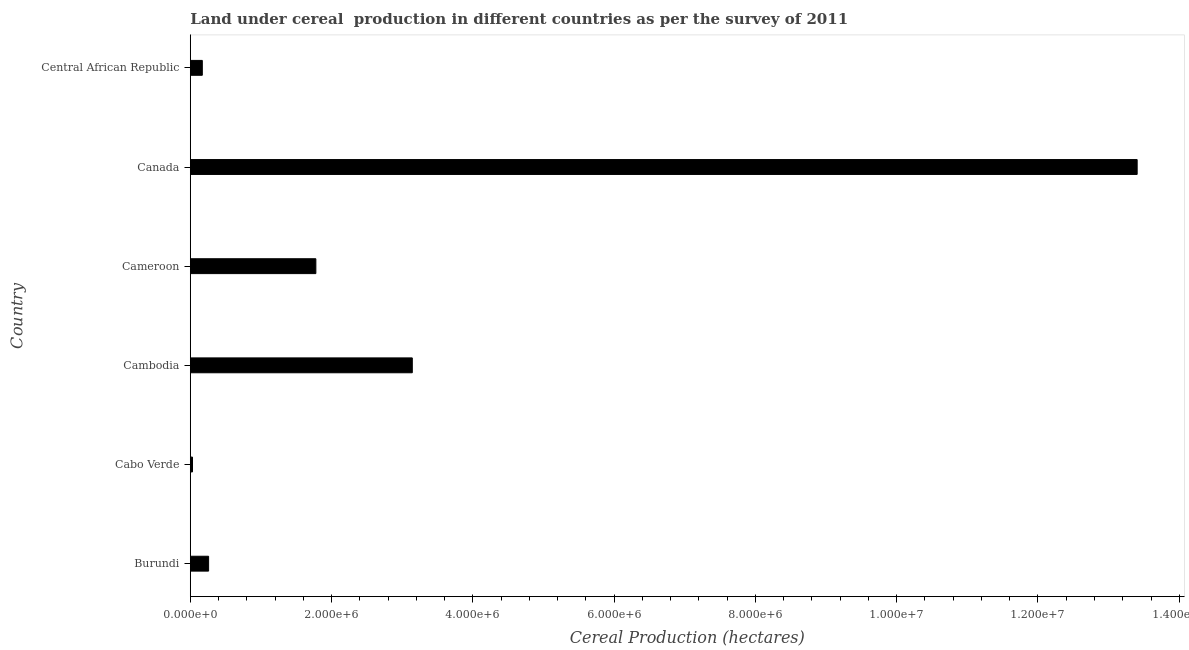What is the title of the graph?
Your response must be concise. Land under cereal  production in different countries as per the survey of 2011. What is the label or title of the X-axis?
Make the answer very short. Cereal Production (hectares). What is the land under cereal production in Cabo Verde?
Make the answer very short. 3.13e+04. Across all countries, what is the maximum land under cereal production?
Make the answer very short. 1.34e+07. Across all countries, what is the minimum land under cereal production?
Offer a very short reply. 3.13e+04. In which country was the land under cereal production minimum?
Your answer should be very brief. Cabo Verde. What is the sum of the land under cereal production?
Offer a terse response. 1.88e+07. What is the difference between the land under cereal production in Cambodia and Canada?
Your response must be concise. -1.03e+07. What is the average land under cereal production per country?
Keep it short and to the point. 3.13e+06. What is the median land under cereal production?
Offer a very short reply. 1.02e+06. What is the ratio of the land under cereal production in Canada to that in Central African Republic?
Keep it short and to the point. 78.75. Is the land under cereal production in Canada less than that in Central African Republic?
Offer a very short reply. No. What is the difference between the highest and the second highest land under cereal production?
Your response must be concise. 1.03e+07. Is the sum of the land under cereal production in Cabo Verde and Central African Republic greater than the maximum land under cereal production across all countries?
Offer a very short reply. No. What is the difference between the highest and the lowest land under cereal production?
Your answer should be very brief. 1.34e+07. In how many countries, is the land under cereal production greater than the average land under cereal production taken over all countries?
Provide a short and direct response. 2. Are all the bars in the graph horizontal?
Keep it short and to the point. Yes. How many countries are there in the graph?
Provide a short and direct response. 6. Are the values on the major ticks of X-axis written in scientific E-notation?
Your answer should be compact. Yes. What is the Cereal Production (hectares) in Burundi?
Make the answer very short. 2.59e+05. What is the Cereal Production (hectares) in Cabo Verde?
Give a very brief answer. 3.13e+04. What is the Cereal Production (hectares) in Cambodia?
Ensure brevity in your answer.  3.14e+06. What is the Cereal Production (hectares) in Cameroon?
Keep it short and to the point. 1.78e+06. What is the Cereal Production (hectares) of Canada?
Offer a terse response. 1.34e+07. What is the Cereal Production (hectares) in Central African Republic?
Provide a short and direct response. 1.70e+05. What is the difference between the Cereal Production (hectares) in Burundi and Cabo Verde?
Keep it short and to the point. 2.28e+05. What is the difference between the Cereal Production (hectares) in Burundi and Cambodia?
Make the answer very short. -2.88e+06. What is the difference between the Cereal Production (hectares) in Burundi and Cameroon?
Give a very brief answer. -1.52e+06. What is the difference between the Cereal Production (hectares) in Burundi and Canada?
Offer a terse response. -1.31e+07. What is the difference between the Cereal Production (hectares) in Burundi and Central African Republic?
Offer a terse response. 8.90e+04. What is the difference between the Cereal Production (hectares) in Cabo Verde and Cambodia?
Your answer should be compact. -3.11e+06. What is the difference between the Cereal Production (hectares) in Cabo Verde and Cameroon?
Ensure brevity in your answer.  -1.75e+06. What is the difference between the Cereal Production (hectares) in Cabo Verde and Canada?
Your response must be concise. -1.34e+07. What is the difference between the Cereal Production (hectares) in Cabo Verde and Central African Republic?
Offer a terse response. -1.39e+05. What is the difference between the Cereal Production (hectares) in Cambodia and Cameroon?
Your response must be concise. 1.37e+06. What is the difference between the Cereal Production (hectares) in Cambodia and Canada?
Offer a very short reply. -1.03e+07. What is the difference between the Cereal Production (hectares) in Cambodia and Central African Republic?
Offer a very short reply. 2.97e+06. What is the difference between the Cereal Production (hectares) in Cameroon and Canada?
Offer a very short reply. -1.16e+07. What is the difference between the Cereal Production (hectares) in Cameroon and Central African Republic?
Keep it short and to the point. 1.61e+06. What is the difference between the Cereal Production (hectares) in Canada and Central African Republic?
Make the answer very short. 1.32e+07. What is the ratio of the Cereal Production (hectares) in Burundi to that in Cabo Verde?
Offer a very short reply. 8.28. What is the ratio of the Cereal Production (hectares) in Burundi to that in Cambodia?
Provide a short and direct response. 0.08. What is the ratio of the Cereal Production (hectares) in Burundi to that in Cameroon?
Keep it short and to the point. 0.15. What is the ratio of the Cereal Production (hectares) in Burundi to that in Canada?
Keep it short and to the point. 0.02. What is the ratio of the Cereal Production (hectares) in Burundi to that in Central African Republic?
Your answer should be very brief. 1.52. What is the ratio of the Cereal Production (hectares) in Cabo Verde to that in Cameroon?
Your answer should be compact. 0.02. What is the ratio of the Cereal Production (hectares) in Cabo Verde to that in Canada?
Ensure brevity in your answer.  0. What is the ratio of the Cereal Production (hectares) in Cabo Verde to that in Central African Republic?
Keep it short and to the point. 0.18. What is the ratio of the Cereal Production (hectares) in Cambodia to that in Cameroon?
Offer a terse response. 1.77. What is the ratio of the Cereal Production (hectares) in Cambodia to that in Canada?
Give a very brief answer. 0.23. What is the ratio of the Cereal Production (hectares) in Cambodia to that in Central African Republic?
Your answer should be very brief. 18.46. What is the ratio of the Cereal Production (hectares) in Cameroon to that in Canada?
Keep it short and to the point. 0.13. What is the ratio of the Cereal Production (hectares) in Cameroon to that in Central African Republic?
Ensure brevity in your answer.  10.44. What is the ratio of the Cereal Production (hectares) in Canada to that in Central African Republic?
Ensure brevity in your answer.  78.75. 